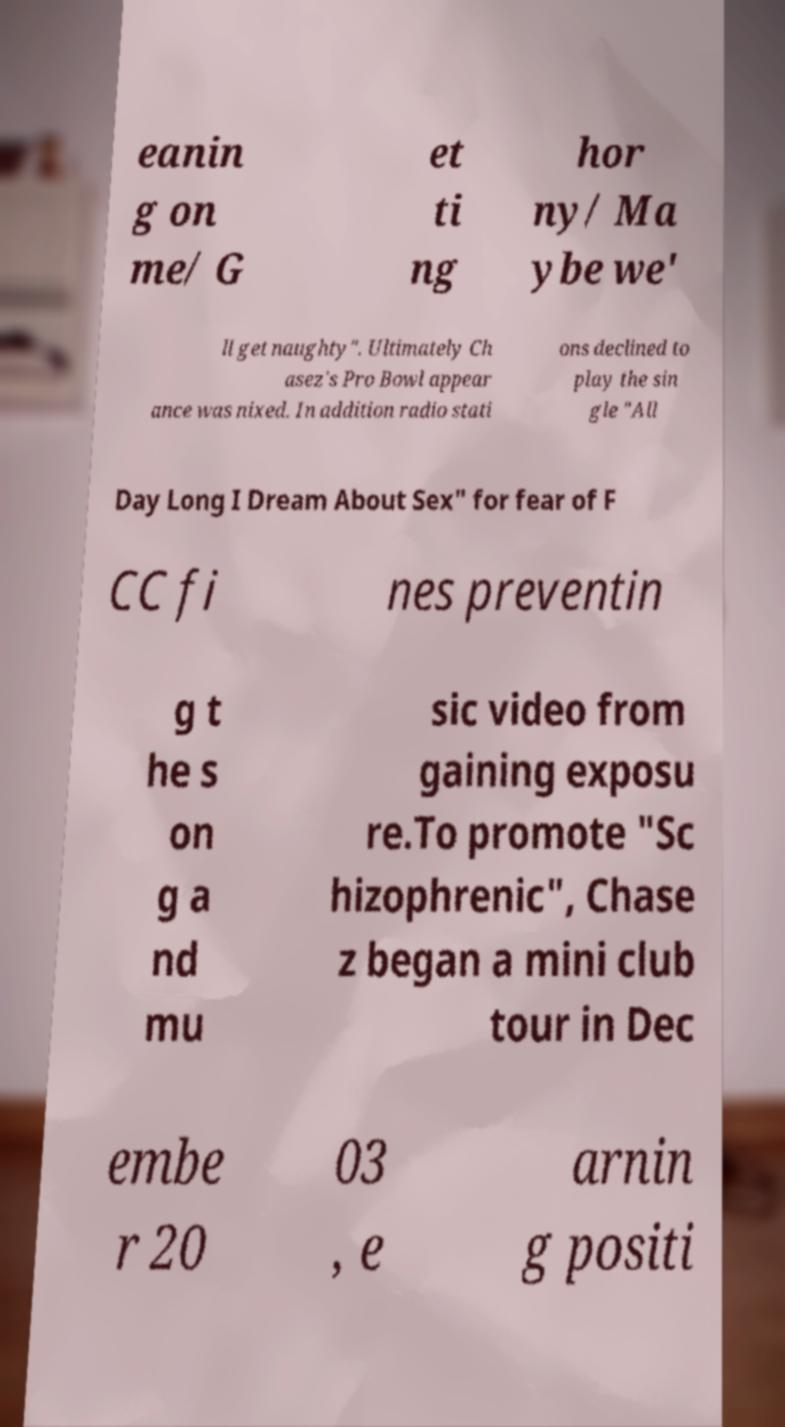Could you assist in decoding the text presented in this image and type it out clearly? eanin g on me/ G et ti ng hor ny/ Ma ybe we' ll get naughty". Ultimately Ch asez's Pro Bowl appear ance was nixed. In addition radio stati ons declined to play the sin gle "All Day Long I Dream About Sex" for fear of F CC fi nes preventin g t he s on g a nd mu sic video from gaining exposu re.To promote "Sc hizophrenic", Chase z began a mini club tour in Dec embe r 20 03 , e arnin g positi 